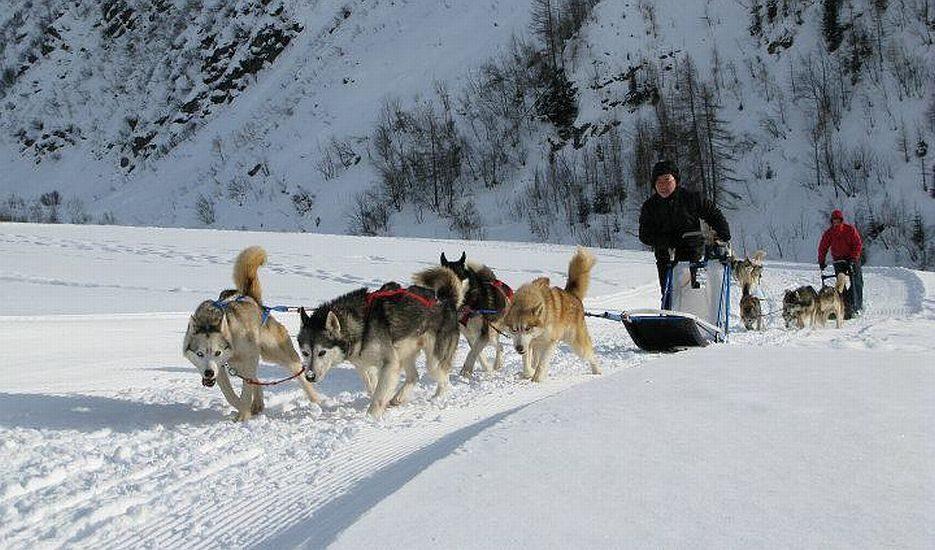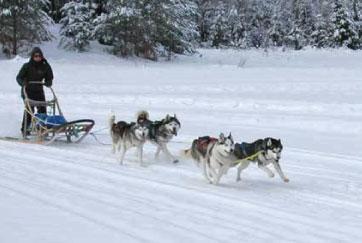The first image is the image on the left, the second image is the image on the right. Analyze the images presented: Is the assertion "A manmade shelter for people is in the background behind a sled dog team moving rightward." valid? Answer yes or no. No. 